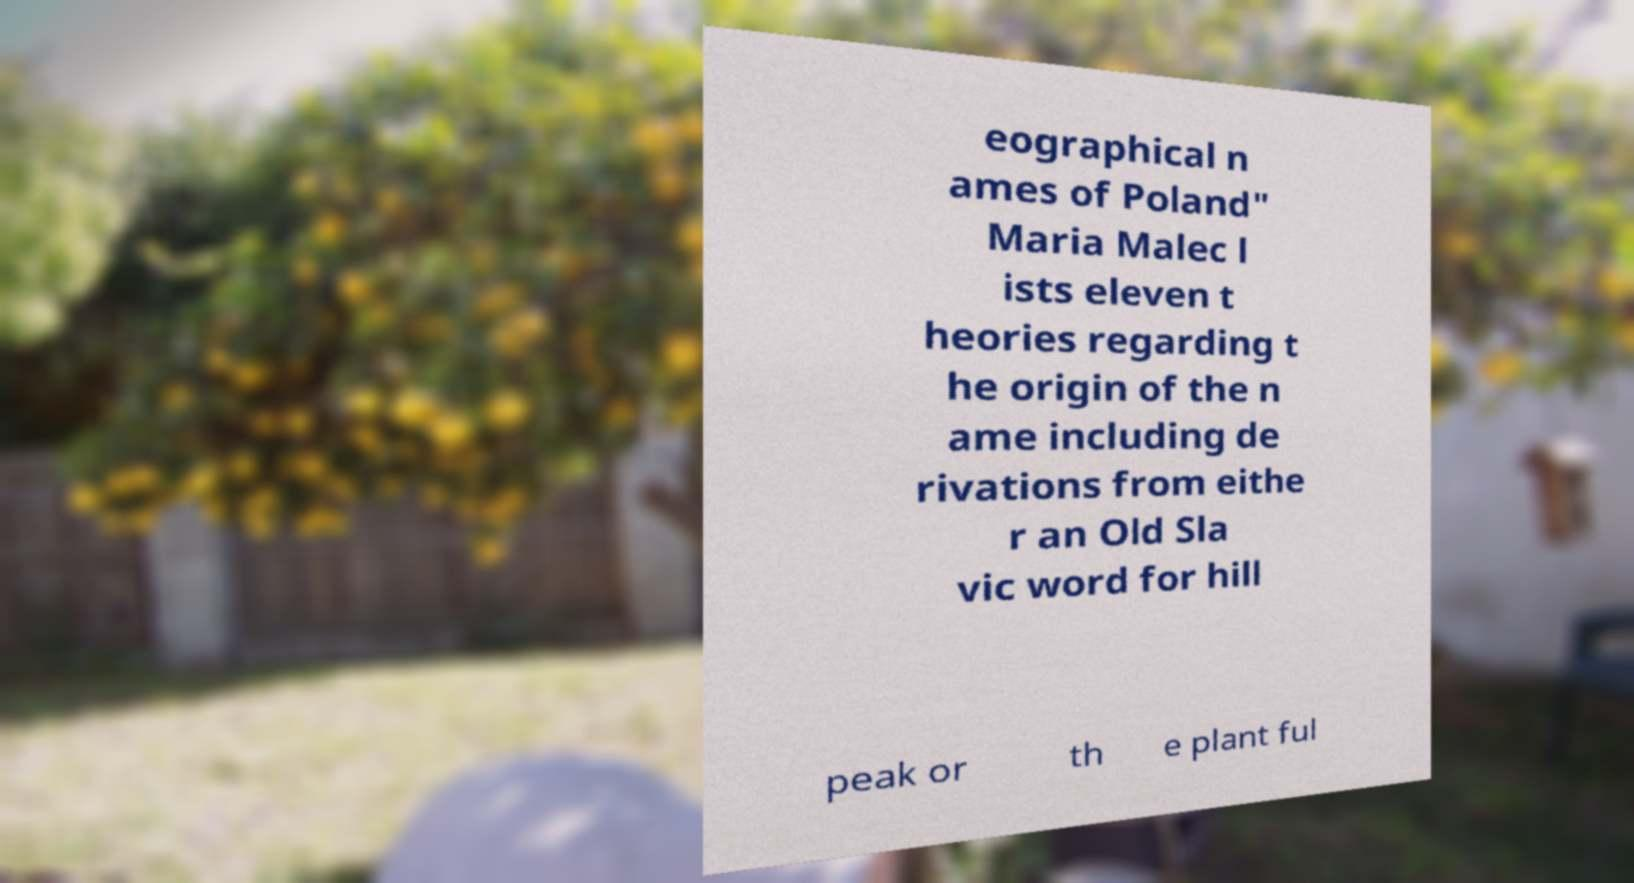Can you read and provide the text displayed in the image?This photo seems to have some interesting text. Can you extract and type it out for me? eographical n ames of Poland" Maria Malec l ists eleven t heories regarding t he origin of the n ame including de rivations from eithe r an Old Sla vic word for hill peak or th e plant ful 